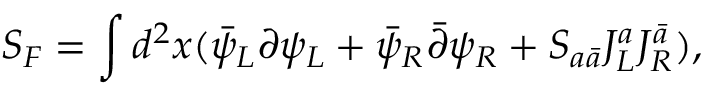Convert formula to latex. <formula><loc_0><loc_0><loc_500><loc_500>S _ { F } = \int d ^ { 2 } x ( \bar { \psi } _ { L } \partial \psi _ { L } + \bar { \psi } _ { R } \bar { \partial } \psi _ { R } + S _ { a \bar { a } } J _ { L } ^ { a } J _ { R } ^ { \bar { a } } ) ,</formula> 